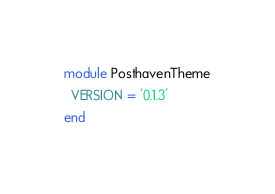<code> <loc_0><loc_0><loc_500><loc_500><_Ruby_>module PosthavenTheme
  VERSION = '0.1.3'
end
</code> 